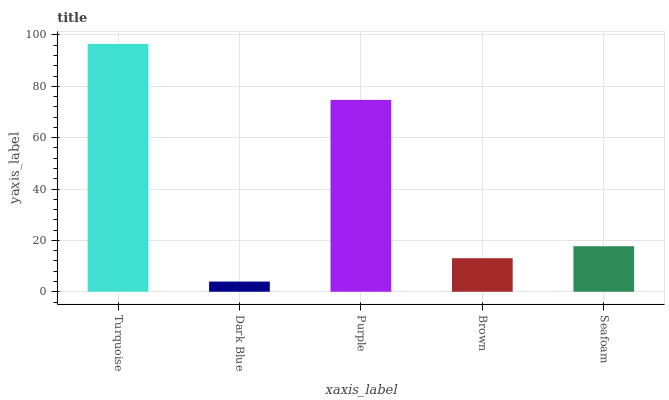Is Dark Blue the minimum?
Answer yes or no. Yes. Is Turquoise the maximum?
Answer yes or no. Yes. Is Purple the minimum?
Answer yes or no. No. Is Purple the maximum?
Answer yes or no. No. Is Purple greater than Dark Blue?
Answer yes or no. Yes. Is Dark Blue less than Purple?
Answer yes or no. Yes. Is Dark Blue greater than Purple?
Answer yes or no. No. Is Purple less than Dark Blue?
Answer yes or no. No. Is Seafoam the high median?
Answer yes or no. Yes. Is Seafoam the low median?
Answer yes or no. Yes. Is Turquoise the high median?
Answer yes or no. No. Is Brown the low median?
Answer yes or no. No. 